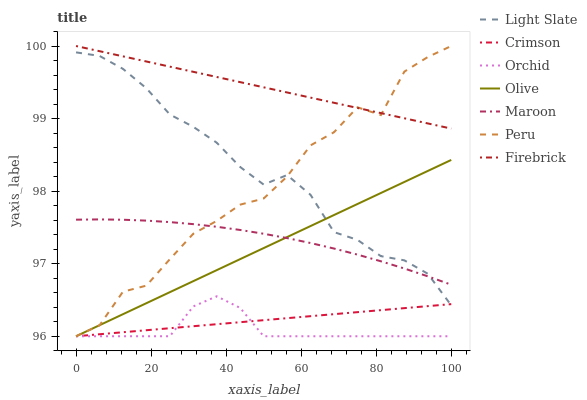Does Maroon have the minimum area under the curve?
Answer yes or no. No. Does Maroon have the maximum area under the curve?
Answer yes or no. No. Is Maroon the smoothest?
Answer yes or no. No. Is Maroon the roughest?
Answer yes or no. No. Does Maroon have the lowest value?
Answer yes or no. No. Does Maroon have the highest value?
Answer yes or no. No. Is Crimson less than Maroon?
Answer yes or no. Yes. Is Maroon greater than Orchid?
Answer yes or no. Yes. Does Crimson intersect Maroon?
Answer yes or no. No. 